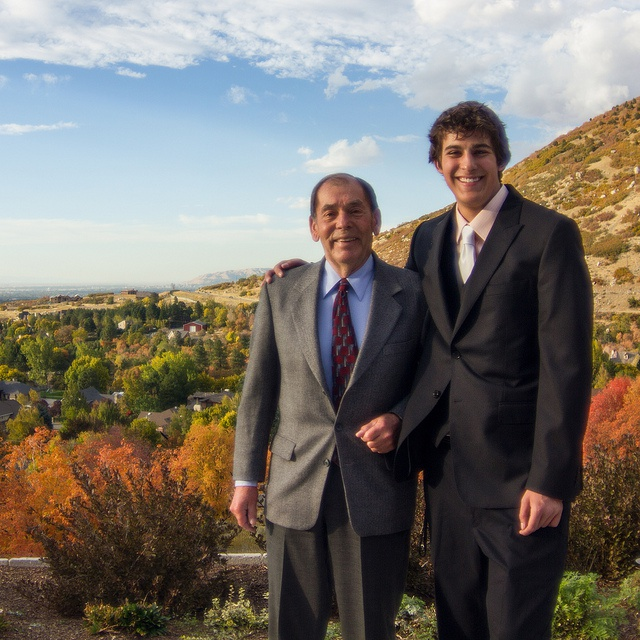Describe the objects in this image and their specific colors. I can see people in lightgray, black, maroon, and brown tones, people in lightgray, black, and gray tones, tie in lightgray, black, maroon, gray, and purple tones, and tie in lightgray, gray, and darkgray tones in this image. 